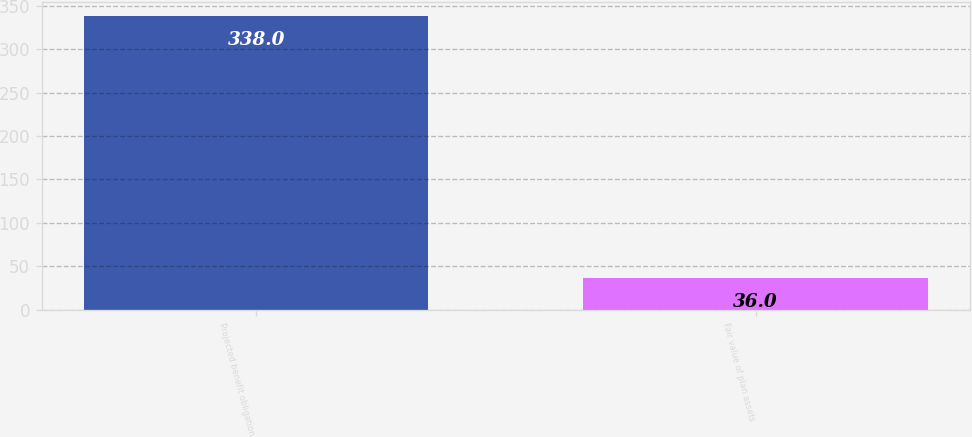<chart> <loc_0><loc_0><loc_500><loc_500><bar_chart><fcel>Projected benefit obligation<fcel>Fair value of plan assets<nl><fcel>338<fcel>36<nl></chart> 